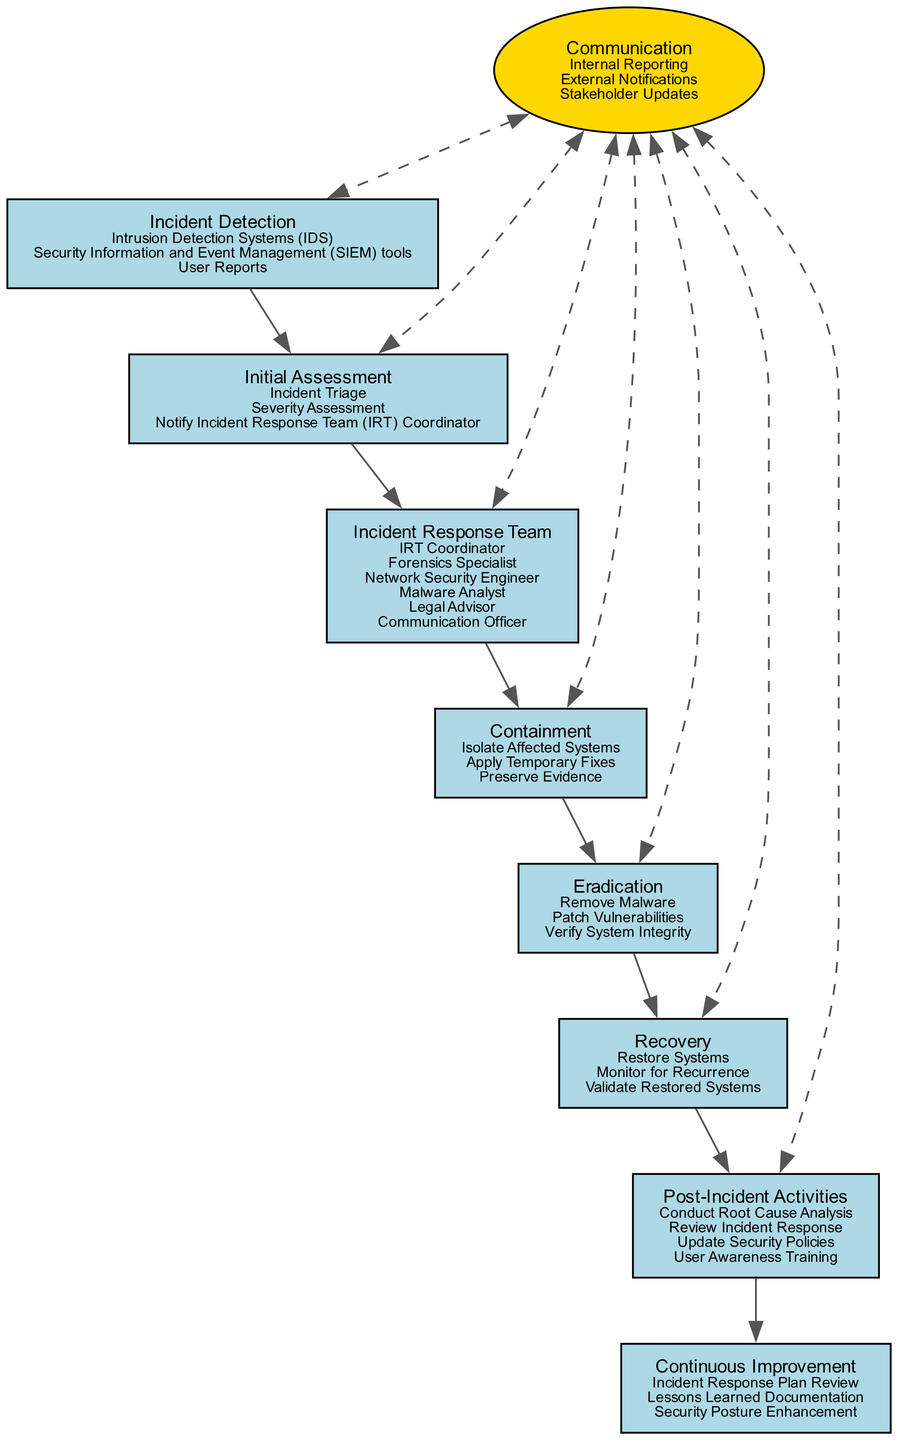What is the first step in the workflow? The first step in the workflow is depicted in the diagram as "Incident Detection." It's the starting point from where the process begins, leading to the next phase.
Answer: Incident Detection How many members are in the Incident Response Team? The diagram lists the individuals who make up the Incident Response Team. By counting these, there are a total of six members.
Answer: 6 What function is associated with the Containment step? The diagram shows that "Isolate Affected Systems" is one of the functions listed under the Containment step, indicating a primary action taken during this phase.
Answer: Isolate Affected Systems Which node has a bidirectional edge with the Communication node? The Communication node connects to multiple nodes with dashed bidirectional edges, and the "Incident Response Team" node is one of those connected nodes, indicating a flow of communication.
Answer: Incident Response Team What is the last step in the workflow? The final step in the workflow is shown in the diagram, where it leads to "Continuous Improvement," marking the end of the primary workflow and emphasizing the need for ongoing enhancement.
Answer: Continuous Improvement What are the three activities under Post-Incident Activities? In the diagram, three distinct functions are detailed under Post-Incident Activities, which include conducting a root cause analysis, reviewing the incident response, and updating security policies.
Answer: Conduct Root Cause Analysis, Review Incident Response, Update Security Policies 